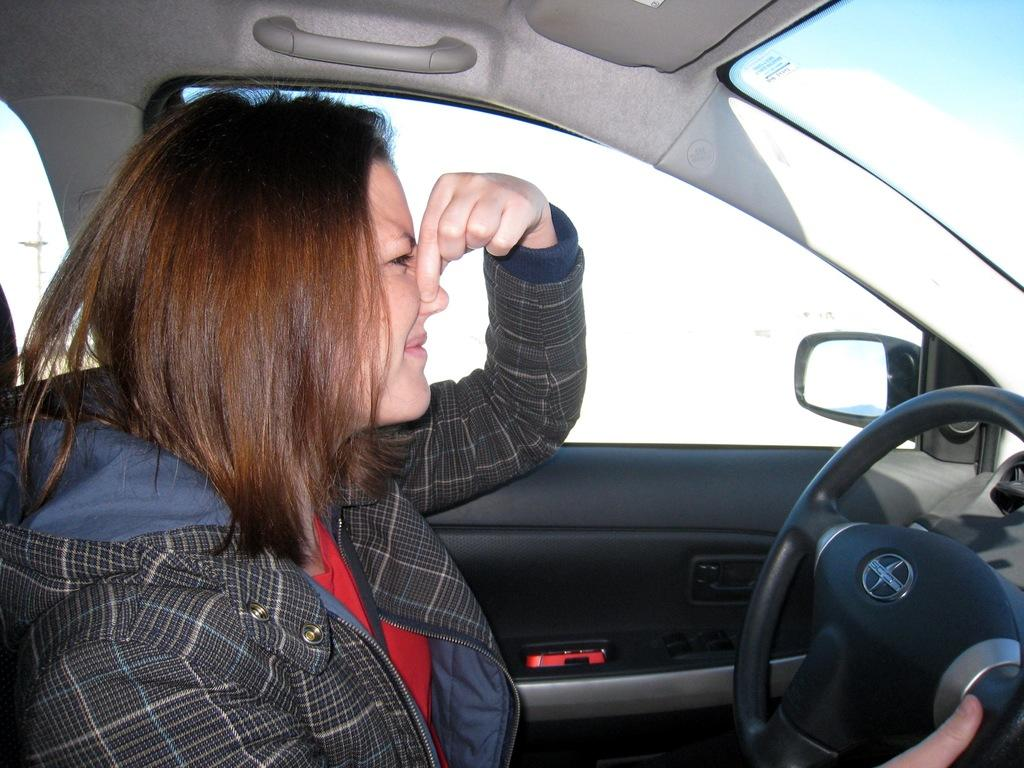Who is the main subject in the image? There is a woman in the image. What is the woman doing in the image? The woman is driving a car. How many notebooks can be seen in the image? There are no notebooks present in the image. What type of lumber is being used to construct the car in the image? The image does not show the car's construction, and there is no mention of lumber. 